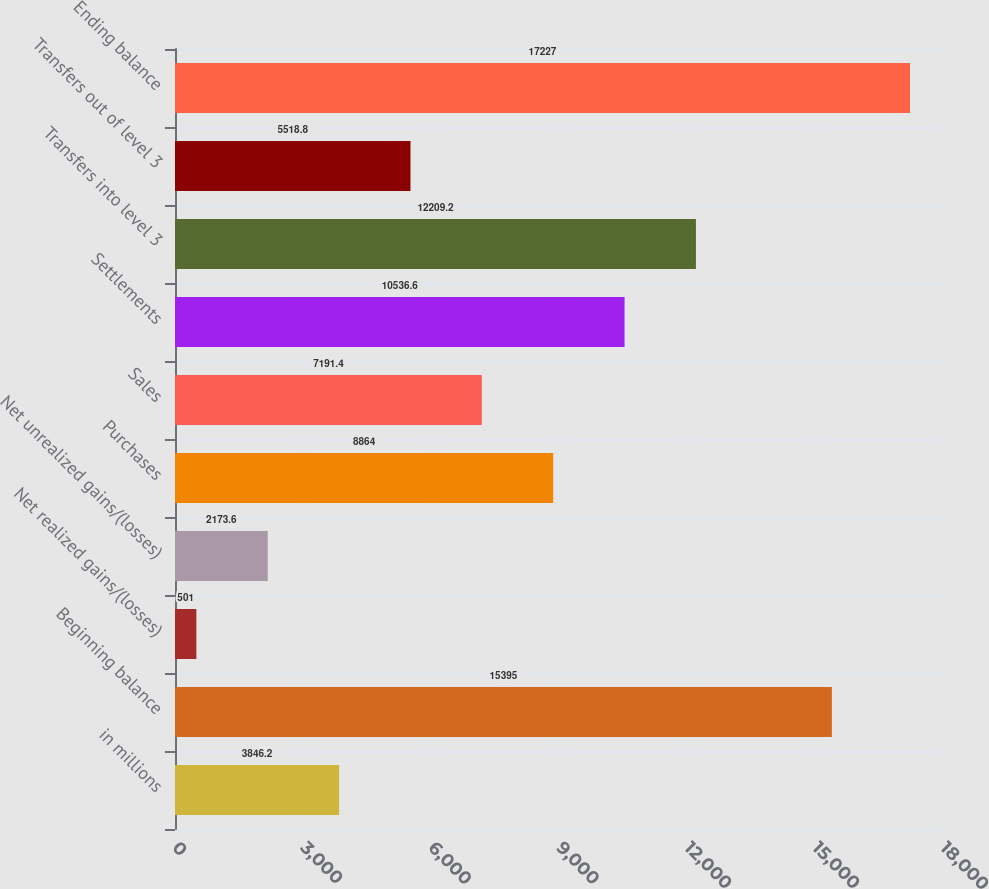Convert chart to OTSL. <chart><loc_0><loc_0><loc_500><loc_500><bar_chart><fcel>in millions<fcel>Beginning balance<fcel>Net realized gains/(losses)<fcel>Net unrealized gains/(losses)<fcel>Purchases<fcel>Sales<fcel>Settlements<fcel>Transfers into level 3<fcel>Transfers out of level 3<fcel>Ending balance<nl><fcel>3846.2<fcel>15395<fcel>501<fcel>2173.6<fcel>8864<fcel>7191.4<fcel>10536.6<fcel>12209.2<fcel>5518.8<fcel>17227<nl></chart> 